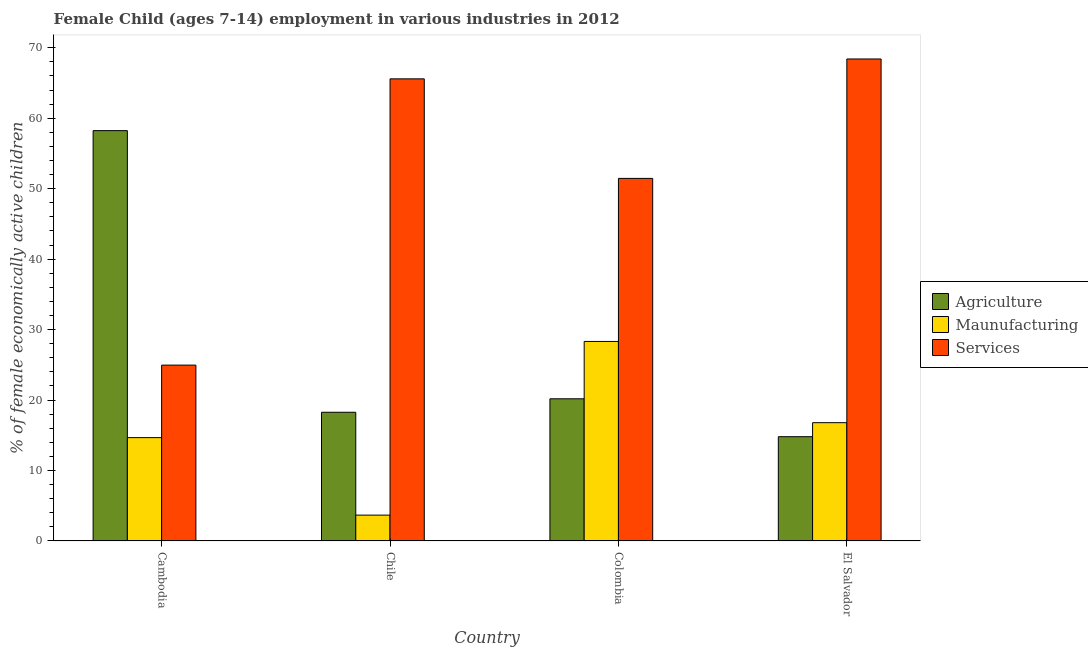How many different coloured bars are there?
Your answer should be very brief. 3. How many groups of bars are there?
Offer a very short reply. 4. Are the number of bars per tick equal to the number of legend labels?
Give a very brief answer. Yes. Are the number of bars on each tick of the X-axis equal?
Provide a succinct answer. Yes. What is the label of the 4th group of bars from the left?
Provide a short and direct response. El Salvador. In how many cases, is the number of bars for a given country not equal to the number of legend labels?
Offer a terse response. 0. What is the percentage of economically active children in agriculture in El Salvador?
Your response must be concise. 14.8. Across all countries, what is the maximum percentage of economically active children in manufacturing?
Provide a succinct answer. 28.32. Across all countries, what is the minimum percentage of economically active children in manufacturing?
Offer a terse response. 3.67. In which country was the percentage of economically active children in agriculture maximum?
Make the answer very short. Cambodia. In which country was the percentage of economically active children in agriculture minimum?
Provide a succinct answer. El Salvador. What is the total percentage of economically active children in manufacturing in the graph?
Provide a short and direct response. 63.45. What is the difference between the percentage of economically active children in services in Cambodia and that in Chile?
Offer a very short reply. -40.63. What is the difference between the percentage of economically active children in manufacturing in Cambodia and the percentage of economically active children in agriculture in Colombia?
Offer a very short reply. -5.51. What is the average percentage of economically active children in manufacturing per country?
Provide a succinct answer. 15.86. What is the difference between the percentage of economically active children in manufacturing and percentage of economically active children in agriculture in Cambodia?
Give a very brief answer. -43.57. In how many countries, is the percentage of economically active children in agriculture greater than 46 %?
Provide a succinct answer. 1. What is the ratio of the percentage of economically active children in agriculture in Cambodia to that in Colombia?
Provide a short and direct response. 2.89. Is the percentage of economically active children in agriculture in Cambodia less than that in Chile?
Provide a short and direct response. No. What is the difference between the highest and the second highest percentage of economically active children in manufacturing?
Make the answer very short. 11.53. What is the difference between the highest and the lowest percentage of economically active children in services?
Give a very brief answer. 43.45. In how many countries, is the percentage of economically active children in manufacturing greater than the average percentage of economically active children in manufacturing taken over all countries?
Your answer should be compact. 2. Is the sum of the percentage of economically active children in manufacturing in Chile and El Salvador greater than the maximum percentage of economically active children in services across all countries?
Keep it short and to the point. No. What does the 2nd bar from the left in Cambodia represents?
Your answer should be very brief. Maunufacturing. What does the 2nd bar from the right in Chile represents?
Your response must be concise. Maunufacturing. How many bars are there?
Offer a terse response. 12. How many countries are there in the graph?
Offer a terse response. 4. Are the values on the major ticks of Y-axis written in scientific E-notation?
Your answer should be very brief. No. Does the graph contain any zero values?
Provide a succinct answer. No. Does the graph contain grids?
Ensure brevity in your answer.  No. How are the legend labels stacked?
Make the answer very short. Vertical. What is the title of the graph?
Offer a very short reply. Female Child (ages 7-14) employment in various industries in 2012. Does "Solid fuel" appear as one of the legend labels in the graph?
Keep it short and to the point. No. What is the label or title of the X-axis?
Offer a terse response. Country. What is the label or title of the Y-axis?
Provide a short and direct response. % of female economically active children. What is the % of female economically active children in Agriculture in Cambodia?
Provide a succinct answer. 58.24. What is the % of female economically active children of Maunufacturing in Cambodia?
Ensure brevity in your answer.  14.67. What is the % of female economically active children in Services in Cambodia?
Your response must be concise. 24.96. What is the % of female economically active children of Agriculture in Chile?
Provide a short and direct response. 18.27. What is the % of female economically active children of Maunufacturing in Chile?
Provide a short and direct response. 3.67. What is the % of female economically active children of Services in Chile?
Your answer should be compact. 65.59. What is the % of female economically active children in Agriculture in Colombia?
Provide a succinct answer. 20.18. What is the % of female economically active children in Maunufacturing in Colombia?
Make the answer very short. 28.32. What is the % of female economically active children of Services in Colombia?
Give a very brief answer. 51.46. What is the % of female economically active children in Maunufacturing in El Salvador?
Make the answer very short. 16.79. What is the % of female economically active children of Services in El Salvador?
Keep it short and to the point. 68.41. Across all countries, what is the maximum % of female economically active children of Agriculture?
Your response must be concise. 58.24. Across all countries, what is the maximum % of female economically active children of Maunufacturing?
Offer a terse response. 28.32. Across all countries, what is the maximum % of female economically active children in Services?
Your answer should be very brief. 68.41. Across all countries, what is the minimum % of female economically active children of Agriculture?
Your answer should be compact. 14.8. Across all countries, what is the minimum % of female economically active children in Maunufacturing?
Offer a very short reply. 3.67. Across all countries, what is the minimum % of female economically active children of Services?
Offer a terse response. 24.96. What is the total % of female economically active children in Agriculture in the graph?
Offer a very short reply. 111.49. What is the total % of female economically active children in Maunufacturing in the graph?
Offer a very short reply. 63.45. What is the total % of female economically active children in Services in the graph?
Provide a short and direct response. 210.42. What is the difference between the % of female economically active children in Agriculture in Cambodia and that in Chile?
Provide a short and direct response. 39.97. What is the difference between the % of female economically active children of Services in Cambodia and that in Chile?
Offer a very short reply. -40.63. What is the difference between the % of female economically active children of Agriculture in Cambodia and that in Colombia?
Your response must be concise. 38.06. What is the difference between the % of female economically active children in Maunufacturing in Cambodia and that in Colombia?
Provide a succinct answer. -13.65. What is the difference between the % of female economically active children in Services in Cambodia and that in Colombia?
Provide a succinct answer. -26.5. What is the difference between the % of female economically active children of Agriculture in Cambodia and that in El Salvador?
Your response must be concise. 43.44. What is the difference between the % of female economically active children in Maunufacturing in Cambodia and that in El Salvador?
Your response must be concise. -2.12. What is the difference between the % of female economically active children in Services in Cambodia and that in El Salvador?
Keep it short and to the point. -43.45. What is the difference between the % of female economically active children in Agriculture in Chile and that in Colombia?
Your answer should be very brief. -1.91. What is the difference between the % of female economically active children of Maunufacturing in Chile and that in Colombia?
Ensure brevity in your answer.  -24.65. What is the difference between the % of female economically active children of Services in Chile and that in Colombia?
Your response must be concise. 14.13. What is the difference between the % of female economically active children in Agriculture in Chile and that in El Salvador?
Provide a short and direct response. 3.47. What is the difference between the % of female economically active children of Maunufacturing in Chile and that in El Salvador?
Your response must be concise. -13.12. What is the difference between the % of female economically active children of Services in Chile and that in El Salvador?
Keep it short and to the point. -2.82. What is the difference between the % of female economically active children in Agriculture in Colombia and that in El Salvador?
Give a very brief answer. 5.38. What is the difference between the % of female economically active children of Maunufacturing in Colombia and that in El Salvador?
Your answer should be very brief. 11.53. What is the difference between the % of female economically active children of Services in Colombia and that in El Salvador?
Provide a short and direct response. -16.95. What is the difference between the % of female economically active children in Agriculture in Cambodia and the % of female economically active children in Maunufacturing in Chile?
Your response must be concise. 54.57. What is the difference between the % of female economically active children in Agriculture in Cambodia and the % of female economically active children in Services in Chile?
Your response must be concise. -7.35. What is the difference between the % of female economically active children of Maunufacturing in Cambodia and the % of female economically active children of Services in Chile?
Give a very brief answer. -50.92. What is the difference between the % of female economically active children in Agriculture in Cambodia and the % of female economically active children in Maunufacturing in Colombia?
Your answer should be compact. 29.92. What is the difference between the % of female economically active children of Agriculture in Cambodia and the % of female economically active children of Services in Colombia?
Provide a succinct answer. 6.78. What is the difference between the % of female economically active children in Maunufacturing in Cambodia and the % of female economically active children in Services in Colombia?
Your response must be concise. -36.79. What is the difference between the % of female economically active children in Agriculture in Cambodia and the % of female economically active children in Maunufacturing in El Salvador?
Your answer should be compact. 41.45. What is the difference between the % of female economically active children of Agriculture in Cambodia and the % of female economically active children of Services in El Salvador?
Your response must be concise. -10.17. What is the difference between the % of female economically active children of Maunufacturing in Cambodia and the % of female economically active children of Services in El Salvador?
Keep it short and to the point. -53.74. What is the difference between the % of female economically active children in Agriculture in Chile and the % of female economically active children in Maunufacturing in Colombia?
Provide a succinct answer. -10.05. What is the difference between the % of female economically active children in Agriculture in Chile and the % of female economically active children in Services in Colombia?
Keep it short and to the point. -33.19. What is the difference between the % of female economically active children of Maunufacturing in Chile and the % of female economically active children of Services in Colombia?
Your response must be concise. -47.79. What is the difference between the % of female economically active children in Agriculture in Chile and the % of female economically active children in Maunufacturing in El Salvador?
Your response must be concise. 1.48. What is the difference between the % of female economically active children of Agriculture in Chile and the % of female economically active children of Services in El Salvador?
Give a very brief answer. -50.14. What is the difference between the % of female economically active children of Maunufacturing in Chile and the % of female economically active children of Services in El Salvador?
Provide a succinct answer. -64.74. What is the difference between the % of female economically active children of Agriculture in Colombia and the % of female economically active children of Maunufacturing in El Salvador?
Keep it short and to the point. 3.39. What is the difference between the % of female economically active children of Agriculture in Colombia and the % of female economically active children of Services in El Salvador?
Your answer should be compact. -48.23. What is the difference between the % of female economically active children of Maunufacturing in Colombia and the % of female economically active children of Services in El Salvador?
Your answer should be very brief. -40.09. What is the average % of female economically active children of Agriculture per country?
Provide a short and direct response. 27.87. What is the average % of female economically active children of Maunufacturing per country?
Provide a succinct answer. 15.86. What is the average % of female economically active children of Services per country?
Offer a very short reply. 52.6. What is the difference between the % of female economically active children in Agriculture and % of female economically active children in Maunufacturing in Cambodia?
Provide a succinct answer. 43.57. What is the difference between the % of female economically active children of Agriculture and % of female economically active children of Services in Cambodia?
Your answer should be very brief. 33.28. What is the difference between the % of female economically active children in Maunufacturing and % of female economically active children in Services in Cambodia?
Your answer should be compact. -10.29. What is the difference between the % of female economically active children of Agriculture and % of female economically active children of Maunufacturing in Chile?
Offer a very short reply. 14.6. What is the difference between the % of female economically active children of Agriculture and % of female economically active children of Services in Chile?
Your response must be concise. -47.32. What is the difference between the % of female economically active children of Maunufacturing and % of female economically active children of Services in Chile?
Offer a terse response. -61.92. What is the difference between the % of female economically active children of Agriculture and % of female economically active children of Maunufacturing in Colombia?
Provide a succinct answer. -8.14. What is the difference between the % of female economically active children of Agriculture and % of female economically active children of Services in Colombia?
Make the answer very short. -31.28. What is the difference between the % of female economically active children in Maunufacturing and % of female economically active children in Services in Colombia?
Give a very brief answer. -23.14. What is the difference between the % of female economically active children in Agriculture and % of female economically active children in Maunufacturing in El Salvador?
Give a very brief answer. -1.99. What is the difference between the % of female economically active children in Agriculture and % of female economically active children in Services in El Salvador?
Your response must be concise. -53.61. What is the difference between the % of female economically active children of Maunufacturing and % of female economically active children of Services in El Salvador?
Give a very brief answer. -51.62. What is the ratio of the % of female economically active children of Agriculture in Cambodia to that in Chile?
Give a very brief answer. 3.19. What is the ratio of the % of female economically active children in Maunufacturing in Cambodia to that in Chile?
Your response must be concise. 4. What is the ratio of the % of female economically active children in Services in Cambodia to that in Chile?
Offer a very short reply. 0.38. What is the ratio of the % of female economically active children of Agriculture in Cambodia to that in Colombia?
Keep it short and to the point. 2.89. What is the ratio of the % of female economically active children in Maunufacturing in Cambodia to that in Colombia?
Give a very brief answer. 0.52. What is the ratio of the % of female economically active children of Services in Cambodia to that in Colombia?
Provide a succinct answer. 0.48. What is the ratio of the % of female economically active children of Agriculture in Cambodia to that in El Salvador?
Ensure brevity in your answer.  3.94. What is the ratio of the % of female economically active children of Maunufacturing in Cambodia to that in El Salvador?
Provide a succinct answer. 0.87. What is the ratio of the % of female economically active children in Services in Cambodia to that in El Salvador?
Your response must be concise. 0.36. What is the ratio of the % of female economically active children of Agriculture in Chile to that in Colombia?
Provide a short and direct response. 0.91. What is the ratio of the % of female economically active children of Maunufacturing in Chile to that in Colombia?
Offer a very short reply. 0.13. What is the ratio of the % of female economically active children of Services in Chile to that in Colombia?
Keep it short and to the point. 1.27. What is the ratio of the % of female economically active children of Agriculture in Chile to that in El Salvador?
Provide a short and direct response. 1.23. What is the ratio of the % of female economically active children of Maunufacturing in Chile to that in El Salvador?
Offer a very short reply. 0.22. What is the ratio of the % of female economically active children in Services in Chile to that in El Salvador?
Offer a very short reply. 0.96. What is the ratio of the % of female economically active children in Agriculture in Colombia to that in El Salvador?
Your answer should be compact. 1.36. What is the ratio of the % of female economically active children of Maunufacturing in Colombia to that in El Salvador?
Make the answer very short. 1.69. What is the ratio of the % of female economically active children of Services in Colombia to that in El Salvador?
Offer a very short reply. 0.75. What is the difference between the highest and the second highest % of female economically active children of Agriculture?
Give a very brief answer. 38.06. What is the difference between the highest and the second highest % of female economically active children in Maunufacturing?
Your response must be concise. 11.53. What is the difference between the highest and the second highest % of female economically active children in Services?
Provide a succinct answer. 2.82. What is the difference between the highest and the lowest % of female economically active children of Agriculture?
Provide a short and direct response. 43.44. What is the difference between the highest and the lowest % of female economically active children of Maunufacturing?
Keep it short and to the point. 24.65. What is the difference between the highest and the lowest % of female economically active children of Services?
Your answer should be very brief. 43.45. 